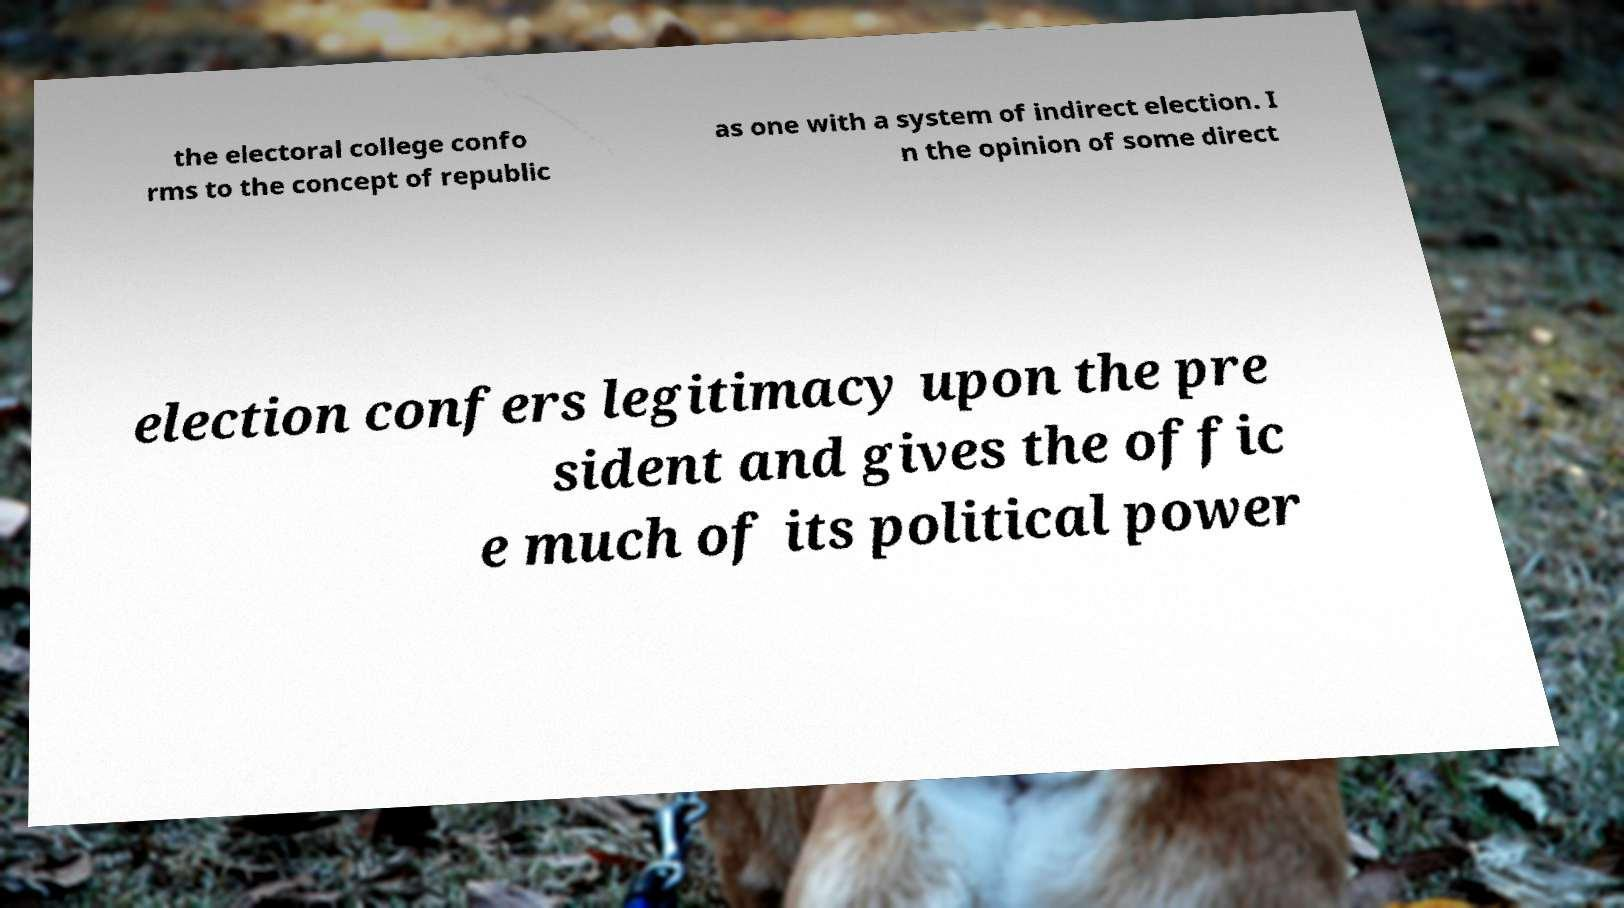Please read and relay the text visible in this image. What does it say? the electoral college confo rms to the concept of republic as one with a system of indirect election. I n the opinion of some direct election confers legitimacy upon the pre sident and gives the offic e much of its political power 